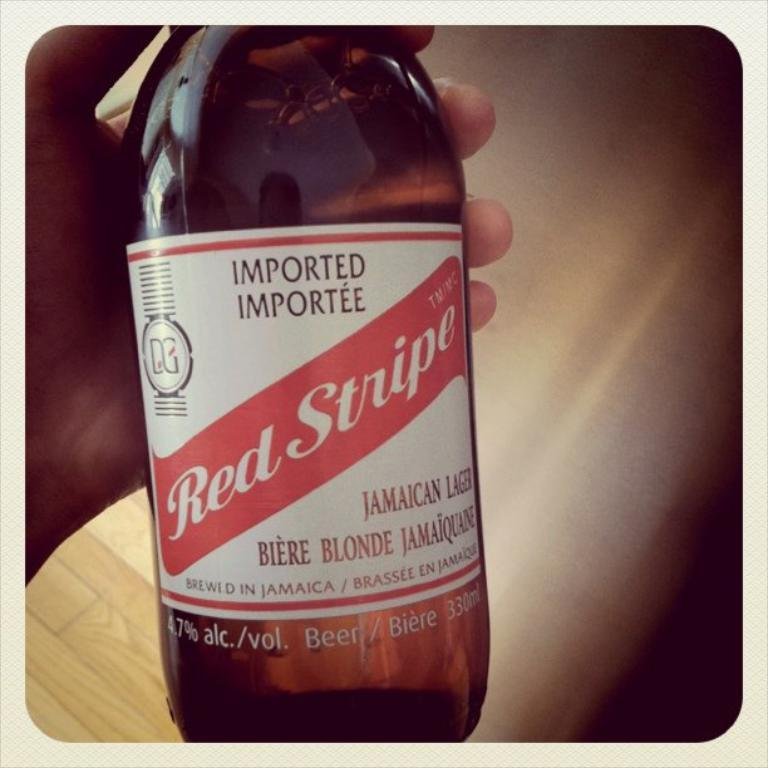What part of a person can be seen in the image? There is a hand of a person in the image. What is the hand holding? The hand is holding a bottle. Can you describe any text or symbols visible in the image? Yes, there is writing visible in the image. What type of chin can be seen in the image? There is no chin visible in the image; it only shows a hand holding a bottle. What invention is being demonstrated in the image? There is no invention being demonstrated in the image; it only shows a hand holding a bottle. 